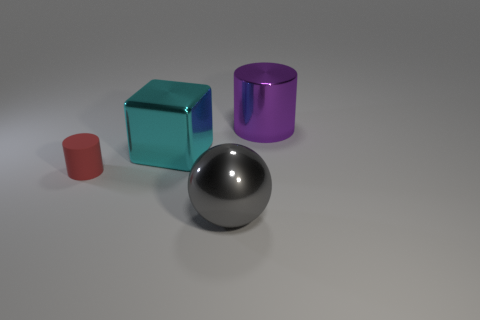Add 4 large cyan objects. How many objects exist? 8 Subtract 1 cylinders. How many cylinders are left? 1 Subtract all purple cylinders. Subtract all cyan cubes. How many cylinders are left? 1 Subtract all big shiny things. Subtract all cyan cubes. How many objects are left? 0 Add 2 large metal cylinders. How many large metal cylinders are left? 3 Add 3 big objects. How many big objects exist? 6 Subtract 1 cyan blocks. How many objects are left? 3 Subtract all blocks. How many objects are left? 3 